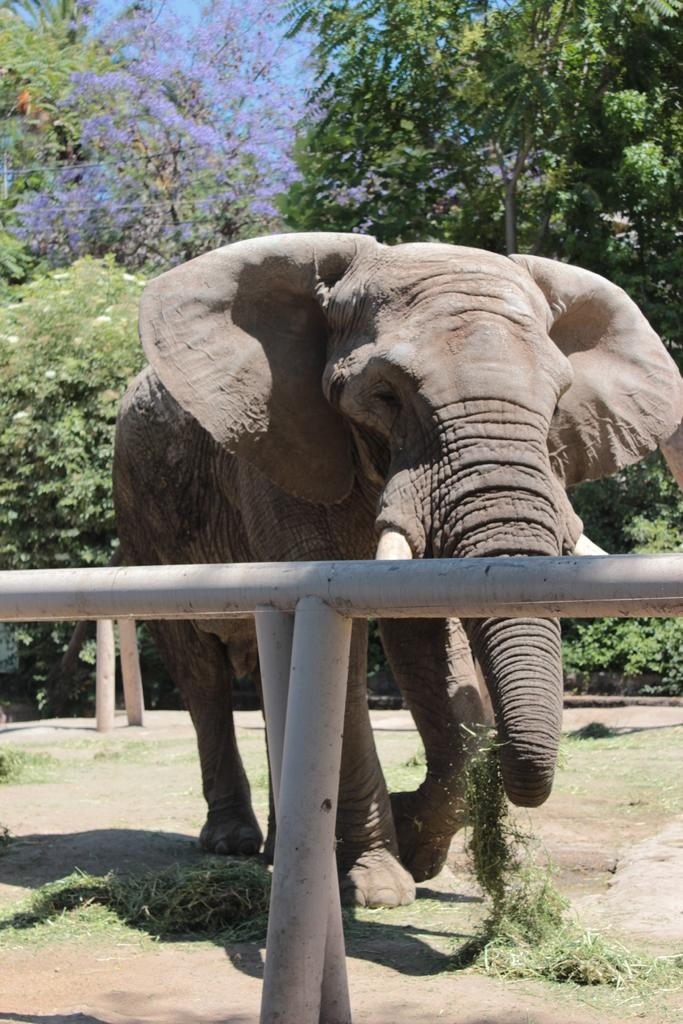What animal is present in the image? There is an elephant in the image. What is the position of the elephant in relation to the pole? The elephant is behind a pole. What is the elephant doing in the image? The elephant is walking towards the pole. What can be seen in the background of the image? There are trees in the background of the image. Where can the sink be found in the image? There is no sink present in the image. What type of building is visible in the background of the image? There is no building visible in the background of the image; only trees are present. 